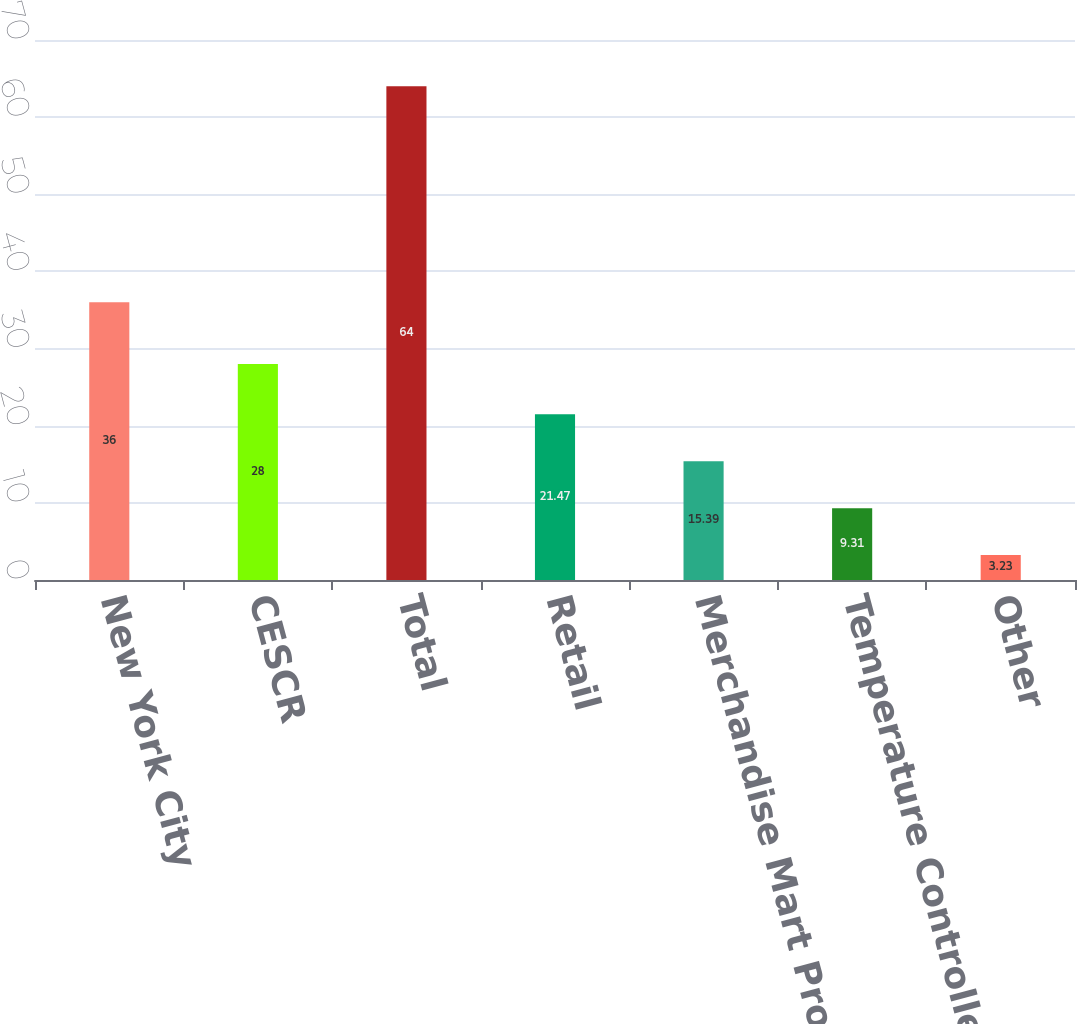Convert chart. <chart><loc_0><loc_0><loc_500><loc_500><bar_chart><fcel>New York City<fcel>CESCR<fcel>Total<fcel>Retail<fcel>Merchandise Mart Properties<fcel>Temperature Controlled<fcel>Other<nl><fcel>36<fcel>28<fcel>64<fcel>21.47<fcel>15.39<fcel>9.31<fcel>3.23<nl></chart> 